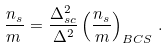Convert formula to latex. <formula><loc_0><loc_0><loc_500><loc_500>\frac { n _ { s } } { m \, } = \frac { \Delta _ { s c } ^ { 2 } } { \Delta ^ { 2 } } \left ( \frac { n _ { s } } { m } \right ) _ { B C S } \, .</formula> 